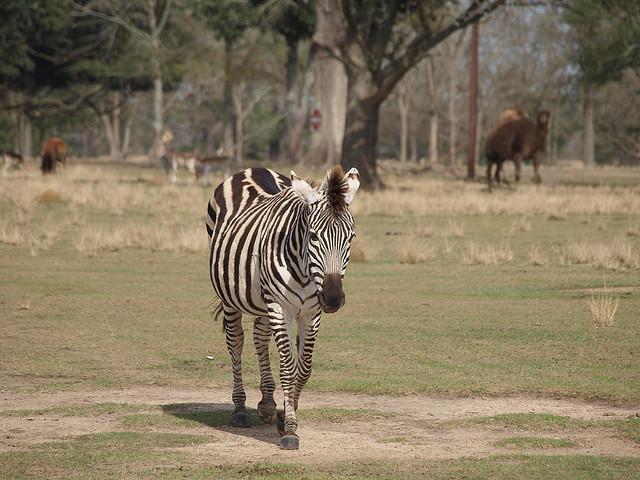Is the ground muddy?
Keep it brief. No. How many animals?
Be succinct. 3. How can you tell this location is not in the wild?
Keep it brief. Sign. What other animal is there besides a zebra?
Be succinct. Camel. How many zebras are there?
Write a very short answer. 1. 